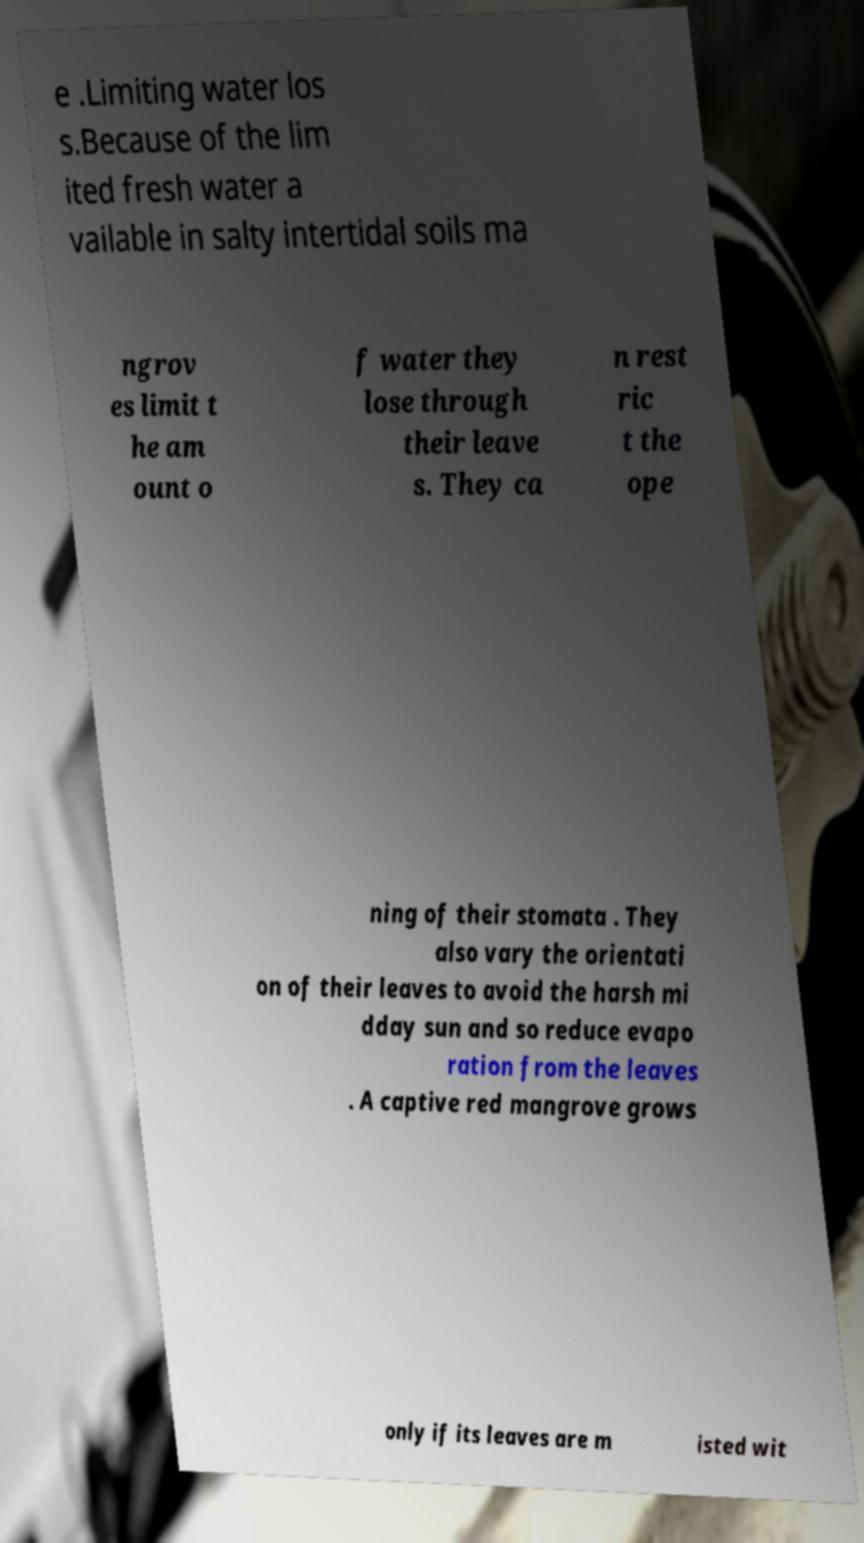Can you accurately transcribe the text from the provided image for me? e .Limiting water los s.Because of the lim ited fresh water a vailable in salty intertidal soils ma ngrov es limit t he am ount o f water they lose through their leave s. They ca n rest ric t the ope ning of their stomata . They also vary the orientati on of their leaves to avoid the harsh mi dday sun and so reduce evapo ration from the leaves . A captive red mangrove grows only if its leaves are m isted wit 